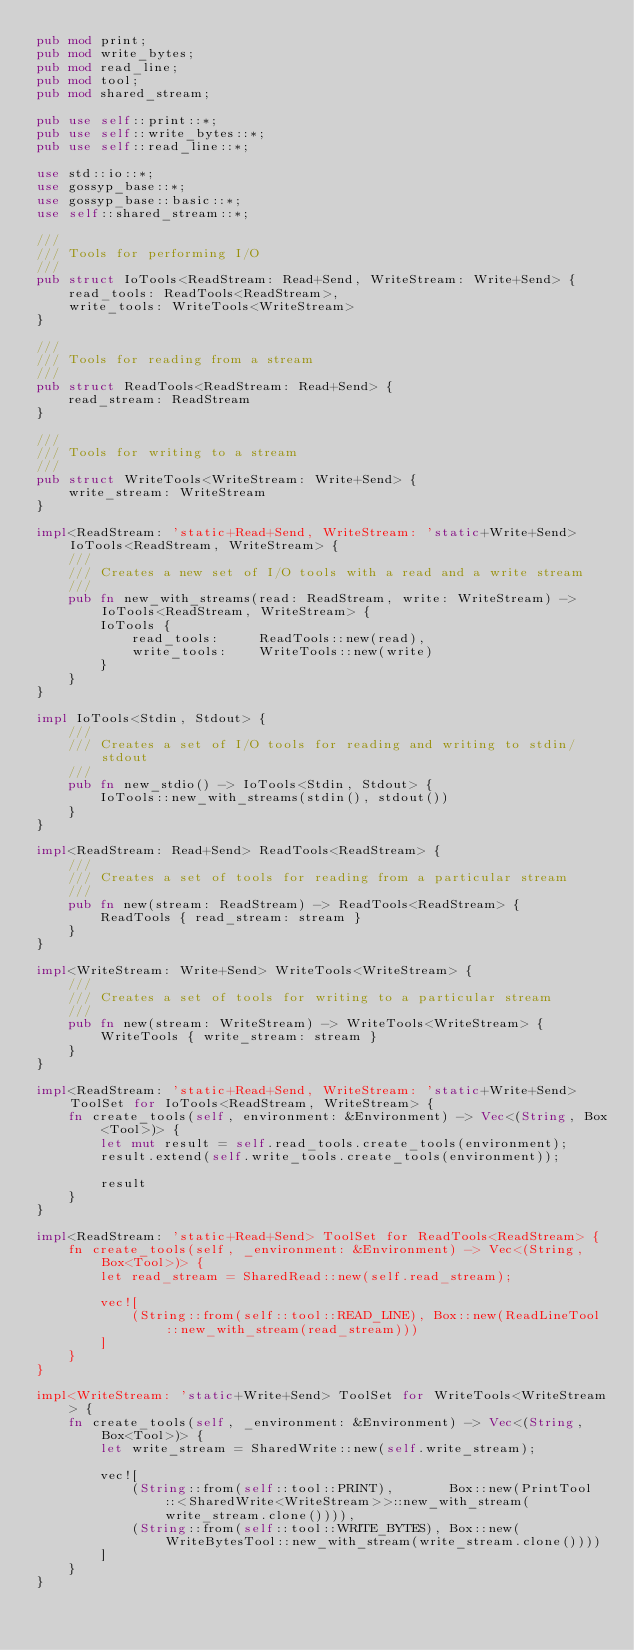<code> <loc_0><loc_0><loc_500><loc_500><_Rust_>pub mod print;
pub mod write_bytes;
pub mod read_line;
pub mod tool;
pub mod shared_stream;

pub use self::print::*;
pub use self::write_bytes::*;
pub use self::read_line::*;

use std::io::*;
use gossyp_base::*;
use gossyp_base::basic::*;
use self::shared_stream::*;

///
/// Tools for performing I/O
///
pub struct IoTools<ReadStream: Read+Send, WriteStream: Write+Send> {
    read_tools: ReadTools<ReadStream>,
    write_tools: WriteTools<WriteStream>
}

///
/// Tools for reading from a stream
///
pub struct ReadTools<ReadStream: Read+Send> {
    read_stream: ReadStream
}

///
/// Tools for writing to a stream
///
pub struct WriteTools<WriteStream: Write+Send> {
    write_stream: WriteStream
}

impl<ReadStream: 'static+Read+Send, WriteStream: 'static+Write+Send> IoTools<ReadStream, WriteStream> {
    ///
    /// Creates a new set of I/O tools with a read and a write stream
    ///
    pub fn new_with_streams(read: ReadStream, write: WriteStream) -> IoTools<ReadStream, WriteStream> {
        IoTools {
            read_tools:     ReadTools::new(read),
            write_tools:    WriteTools::new(write)
        }
    }
}

impl IoTools<Stdin, Stdout> {
    ///
    /// Creates a set of I/O tools for reading and writing to stdin/stdout
    ///
    pub fn new_stdio() -> IoTools<Stdin, Stdout> {
        IoTools::new_with_streams(stdin(), stdout())
    }
}

impl<ReadStream: Read+Send> ReadTools<ReadStream> {
    ///
    /// Creates a set of tools for reading from a particular stream
    ///
    pub fn new(stream: ReadStream) -> ReadTools<ReadStream> {
        ReadTools { read_stream: stream }
    }
}

impl<WriteStream: Write+Send> WriteTools<WriteStream> {
    ///
    /// Creates a set of tools for writing to a particular stream
    ///
    pub fn new(stream: WriteStream) -> WriteTools<WriteStream> {
        WriteTools { write_stream: stream }
    }
}

impl<ReadStream: 'static+Read+Send, WriteStream: 'static+Write+Send> ToolSet for IoTools<ReadStream, WriteStream> {
    fn create_tools(self, environment: &Environment) -> Vec<(String, Box<Tool>)> {
        let mut result = self.read_tools.create_tools(environment);
        result.extend(self.write_tools.create_tools(environment));

        result
    }
}

impl<ReadStream: 'static+Read+Send> ToolSet for ReadTools<ReadStream> {
    fn create_tools(self, _environment: &Environment) -> Vec<(String, Box<Tool>)> {
        let read_stream = SharedRead::new(self.read_stream);

        vec![
            (String::from(self::tool::READ_LINE), Box::new(ReadLineTool::new_with_stream(read_stream)))
        ]
    }
}

impl<WriteStream: 'static+Write+Send> ToolSet for WriteTools<WriteStream> {
    fn create_tools(self, _environment: &Environment) -> Vec<(String, Box<Tool>)> {
        let write_stream = SharedWrite::new(self.write_stream);

        vec![
            (String::from(self::tool::PRINT),       Box::new(PrintTool::<SharedWrite<WriteStream>>::new_with_stream(write_stream.clone()))),
            (String::from(self::tool::WRITE_BYTES), Box::new(WriteBytesTool::new_with_stream(write_stream.clone())))
        ]
    }
}
</code> 